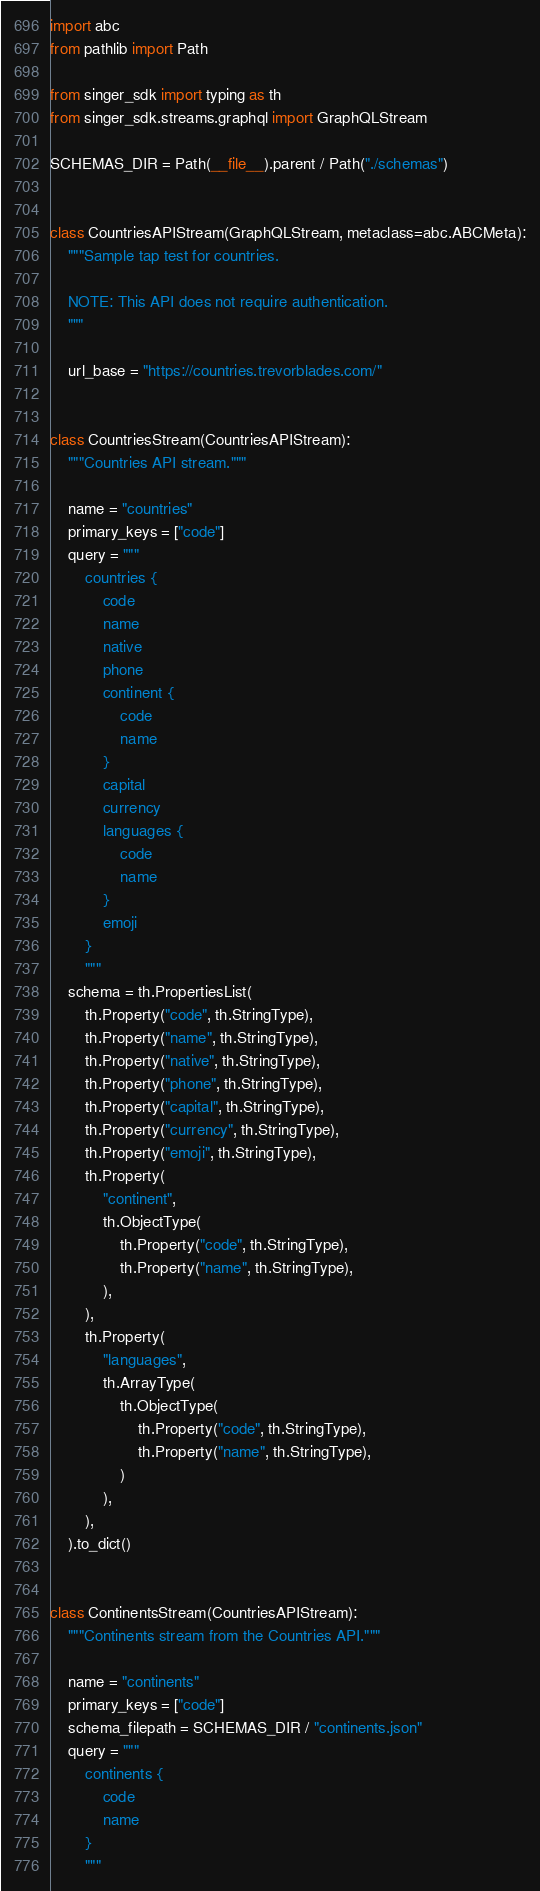Convert code to text. <code><loc_0><loc_0><loc_500><loc_500><_Python_>
import abc
from pathlib import Path

from singer_sdk import typing as th
from singer_sdk.streams.graphql import GraphQLStream

SCHEMAS_DIR = Path(__file__).parent / Path("./schemas")


class CountriesAPIStream(GraphQLStream, metaclass=abc.ABCMeta):
    """Sample tap test for countries.

    NOTE: This API does not require authentication.
    """

    url_base = "https://countries.trevorblades.com/"


class CountriesStream(CountriesAPIStream):
    """Countries API stream."""

    name = "countries"
    primary_keys = ["code"]
    query = """
        countries {
            code
            name
            native
            phone
            continent {
                code
                name
            }
            capital
            currency
            languages {
                code
                name
            }
            emoji
        }
        """
    schema = th.PropertiesList(
        th.Property("code", th.StringType),
        th.Property("name", th.StringType),
        th.Property("native", th.StringType),
        th.Property("phone", th.StringType),
        th.Property("capital", th.StringType),
        th.Property("currency", th.StringType),
        th.Property("emoji", th.StringType),
        th.Property(
            "continent",
            th.ObjectType(
                th.Property("code", th.StringType),
                th.Property("name", th.StringType),
            ),
        ),
        th.Property(
            "languages",
            th.ArrayType(
                th.ObjectType(
                    th.Property("code", th.StringType),
                    th.Property("name", th.StringType),
                )
            ),
        ),
    ).to_dict()


class ContinentsStream(CountriesAPIStream):
    """Continents stream from the Countries API."""

    name = "continents"
    primary_keys = ["code"]
    schema_filepath = SCHEMAS_DIR / "continents.json"
    query = """
        continents {
            code
            name
        }
        """
</code> 